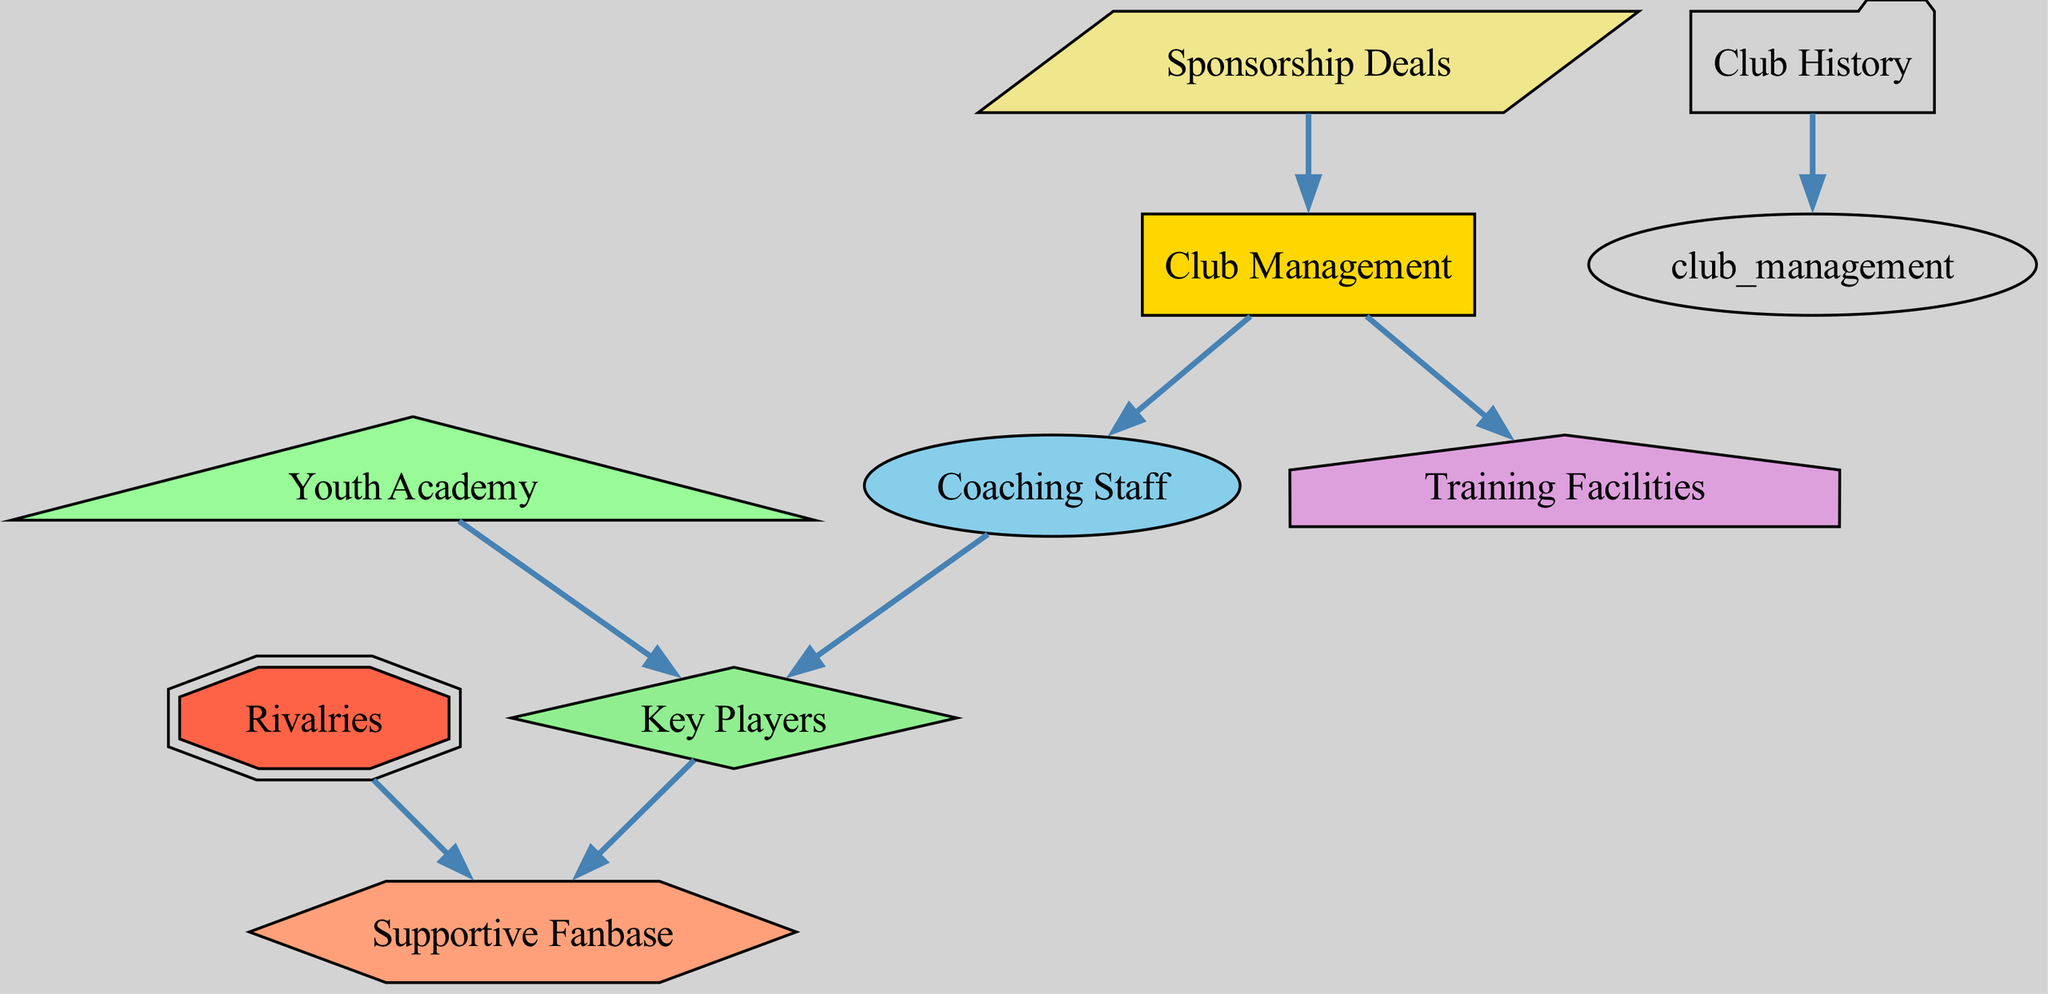What are the key influencers in Catanzaro FC's success? The diagram specifically identifies several key influencers, which are shown as nodes: Club Management, Coaching Staff, Key Players, Supportive Fanbase, Training Facilities, Sponsorship Deals, Youth Academy, Club History, and Rivalries.
Answer: Club Management, Coaching Staff, Key Players, Supportive Fanbase, Training Facilities, Sponsorship Deals, Youth Academy, Club History, Rivalries How many nodes are in the diagram? The diagram lists a total of nine nodes representing different aspects of Catanzaro FC's success. These are Club Management, Coaching Staff, Key Players, Supportive Fanbase, Training Facilities, Sponsorship Deals, Youth Academy, Club History, and Rivalries.
Answer: Nine Which node is connected to both Club Management and Coaching Staff? By examining the edges in the diagram, it's clear that the Coaching Staff node is directly connected to Club Management, indicating a relationship where the management influences the coaching.
Answer: Coaching Staff What category does 'Youth Academy' fall under in the diagram? The 'Youth Academy' node is represented in the diagram, and it specifically shows an influence on the 'Key Players' node. This illustrates its role in developing future talent.
Answer: Development What is the relationship between Key Players and Supportive Fanbase? In the diagram, the 'Key Players' node has a direct edge connecting to the 'Supportive Fanbase'. This indicates that successful players contribute to fan engagement and support.
Answer: Influential Which node indicates financial support for Club Management? The 'Sponsorship Deals' node connects to 'Club Management', suggesting that financial support comes from sponsorships to aid in management operations.
Answer: Sponsorship Deals How does Club History connect to Club Management? The diagram outlines a direct relationship where Club History influences Club Management, indicating that past performances and traditions affect current management decisions.
Answer: Influences How many direct influences does Coaching Staff have? 'Coaching Staff' has one direct influence represented by the edge that points towards 'Key Players', illustrating its role in shaping the team's talent.
Answer: One What type of node is 'Rivalries' classified as? 'Rivalries' is represented in the diagram as a unique node, and its shape and color classify it distinctly among other types. It is in the structure of a double octagon.
Answer: Unique 